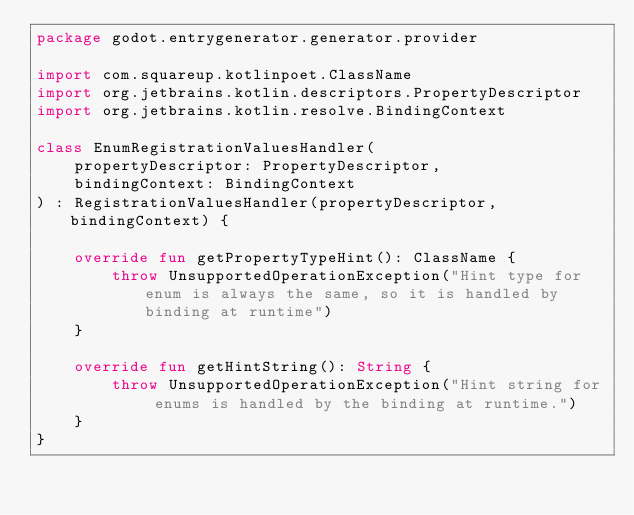<code> <loc_0><loc_0><loc_500><loc_500><_Kotlin_>package godot.entrygenerator.generator.provider

import com.squareup.kotlinpoet.ClassName
import org.jetbrains.kotlin.descriptors.PropertyDescriptor
import org.jetbrains.kotlin.resolve.BindingContext

class EnumRegistrationValuesHandler(
    propertyDescriptor: PropertyDescriptor,
    bindingContext: BindingContext
) : RegistrationValuesHandler(propertyDescriptor, bindingContext) {

    override fun getPropertyTypeHint(): ClassName {
        throw UnsupportedOperationException("Hint type for enum is always the same, so it is handled by binding at runtime")
    }

    override fun getHintString(): String {
        throw UnsupportedOperationException("Hint string for enums is handled by the binding at runtime.")
    }
}
</code> 